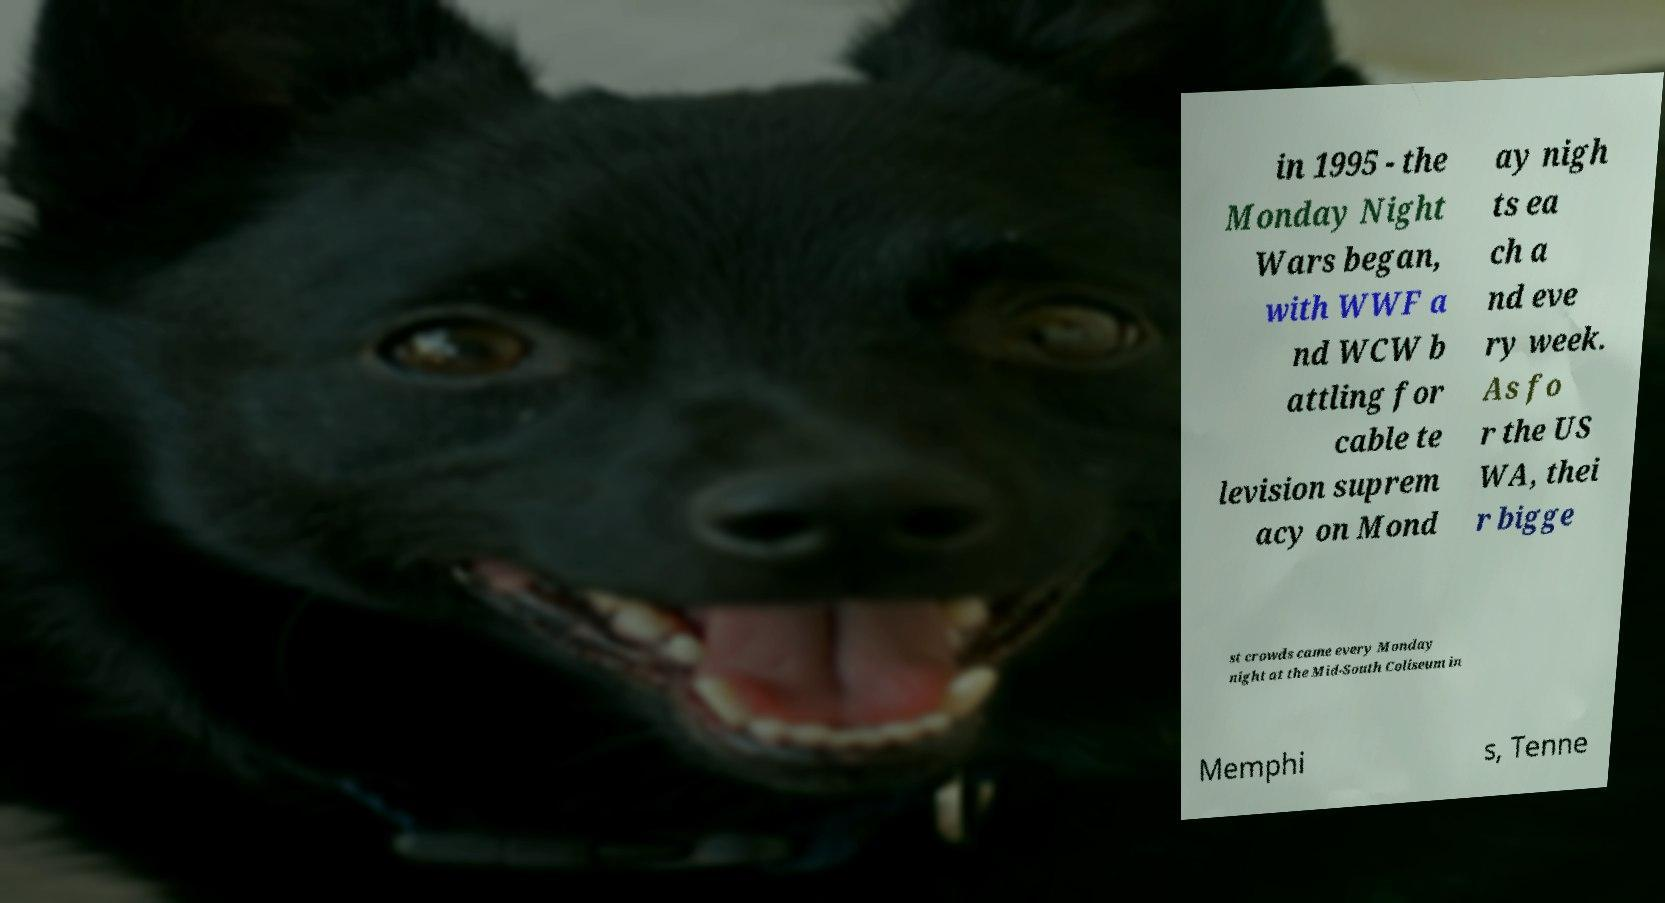There's text embedded in this image that I need extracted. Can you transcribe it verbatim? in 1995 - the Monday Night Wars began, with WWF a nd WCW b attling for cable te levision suprem acy on Mond ay nigh ts ea ch a nd eve ry week. As fo r the US WA, thei r bigge st crowds came every Monday night at the Mid-South Coliseum in Memphi s, Tenne 